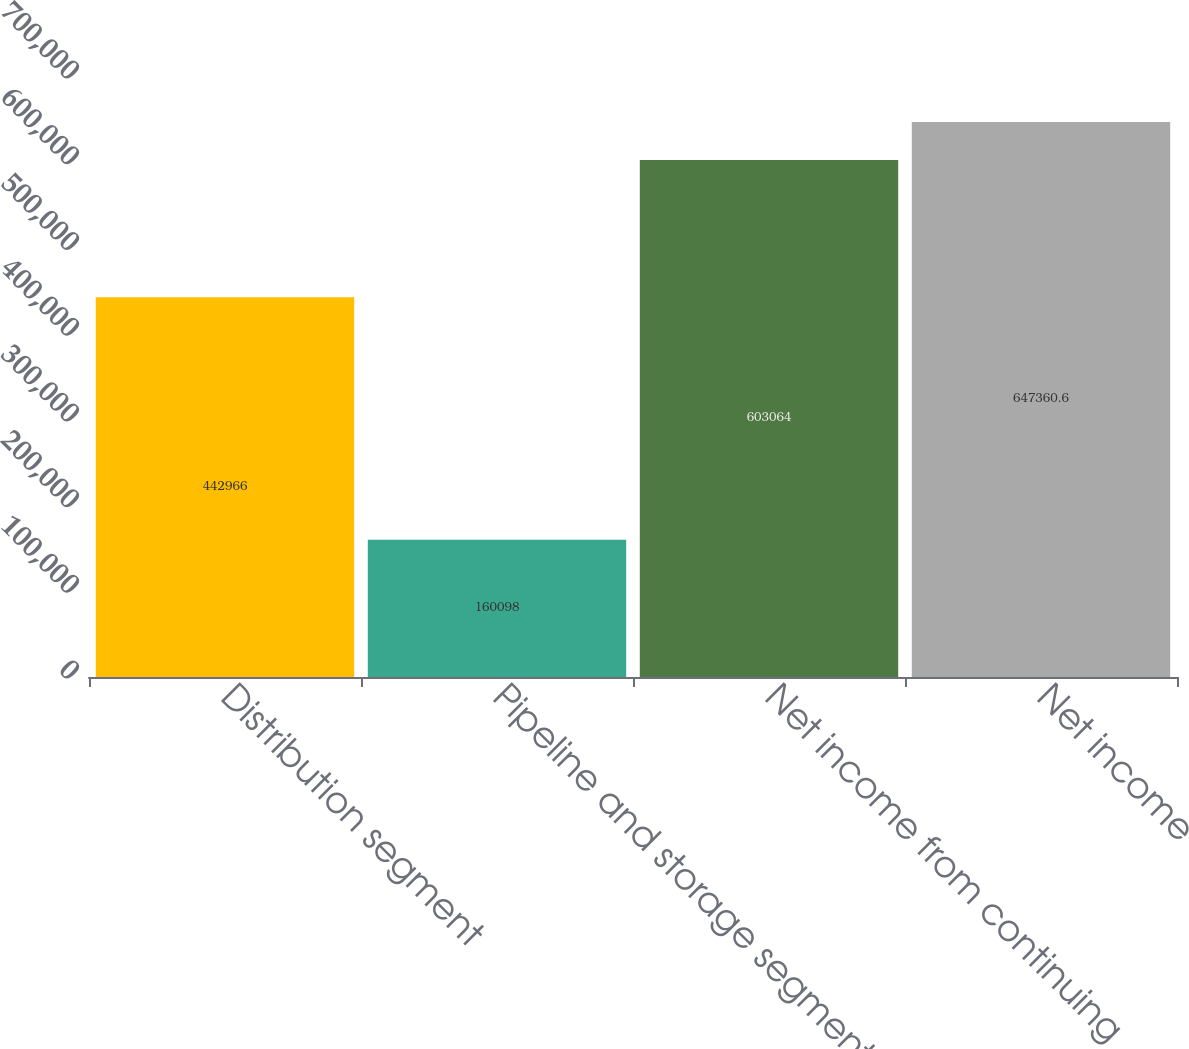<chart> <loc_0><loc_0><loc_500><loc_500><bar_chart><fcel>Distribution segment<fcel>Pipeline and storage segment<fcel>Net income from continuing<fcel>Net income<nl><fcel>442966<fcel>160098<fcel>603064<fcel>647361<nl></chart> 